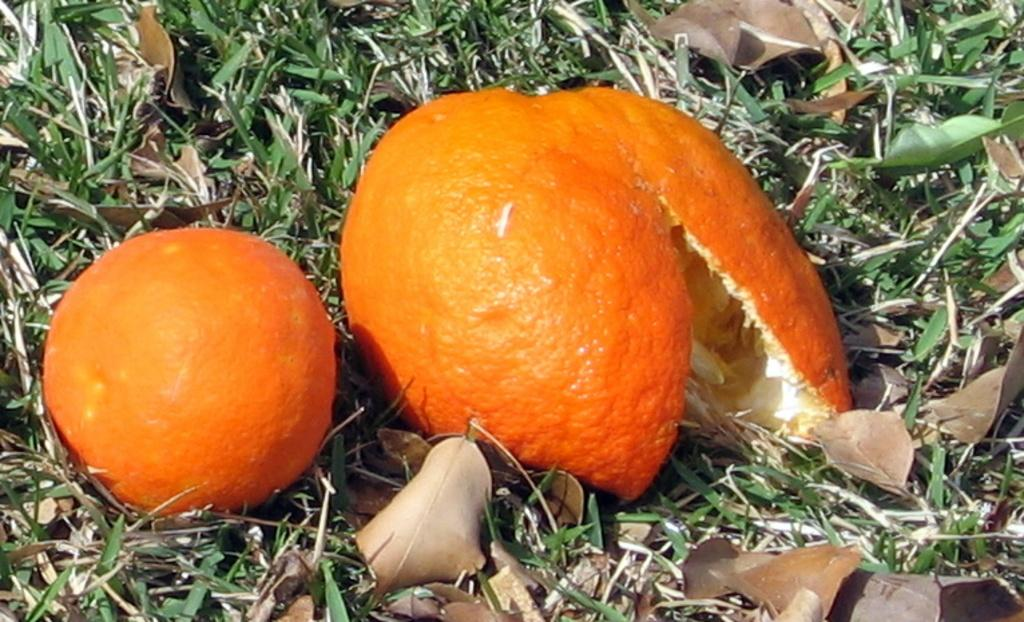What type of fruit is present in the image? There is an orange in the image. What is the condition of the orange in the image? The orange has been peeled, as there is orange peel in the image. Where are the orange and orange peel located? The orange and orange peel are on the grass in the image. What other natural elements can be seen in the image? There are dried leaves in the image. How many cents are visible on the orange in the image? There are no cents present on the orange or in the image. 